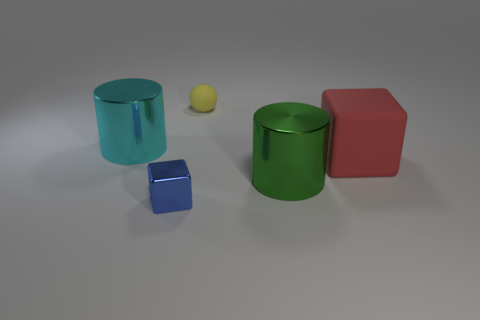There is a tiny thing behind the shiny thing that is right of the small blue metallic thing; how many large rubber things are on the left side of it?
Give a very brief answer. 0. Is there any other thing that has the same color as the large matte object?
Provide a succinct answer. No. What is the color of the metal cylinder that is on the right side of the blue shiny block in front of the big rubber block?
Your answer should be compact. Green. Are any yellow shiny objects visible?
Provide a succinct answer. No. There is a large object that is both on the right side of the cyan cylinder and behind the big green metal cylinder; what is its color?
Provide a short and direct response. Red. There is a metallic thing that is behind the red rubber cube; is its size the same as the thing that is in front of the green metallic object?
Provide a succinct answer. No. What number of other things are the same size as the cyan metallic cylinder?
Make the answer very short. 2. There is a big cylinder that is right of the tiny yellow matte object; what number of big cyan cylinders are behind it?
Your answer should be compact. 1. Are there fewer large cubes in front of the tiny blue shiny cube than red matte cubes?
Provide a short and direct response. Yes. There is a large object that is to the left of the metallic cylinder in front of the metal cylinder behind the large matte cube; what is its shape?
Keep it short and to the point. Cylinder. 